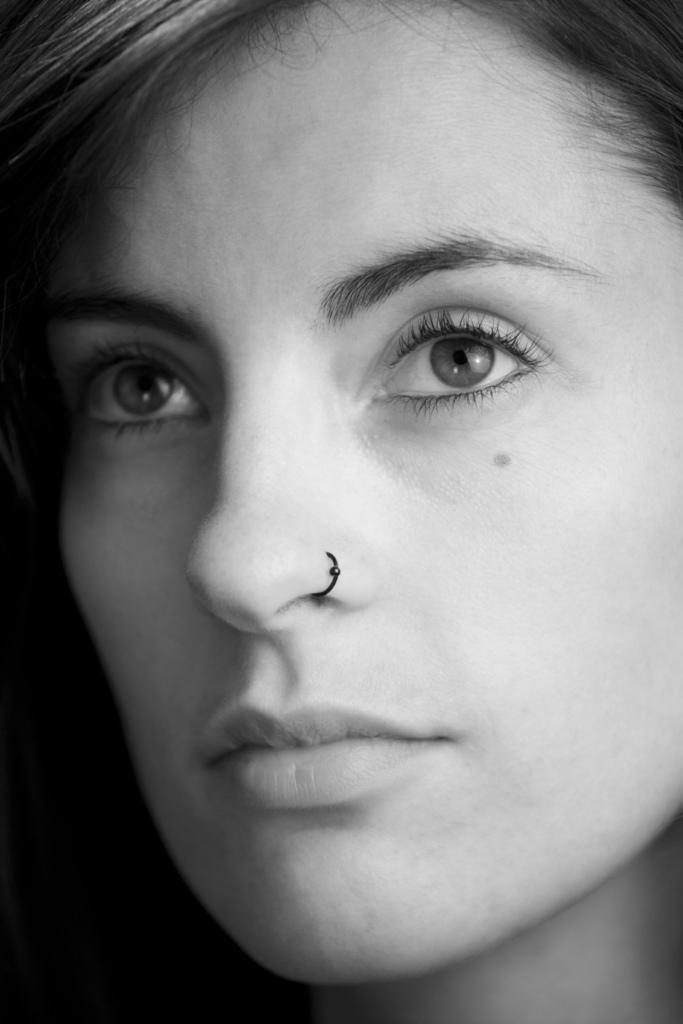Describe this image in one or two sentences. This is a zoomed in picture and we can see the head of a person consists of hairs, eyebrows, eyes, nose, mouth and some objects and we can see the person wearing a nose ring. 